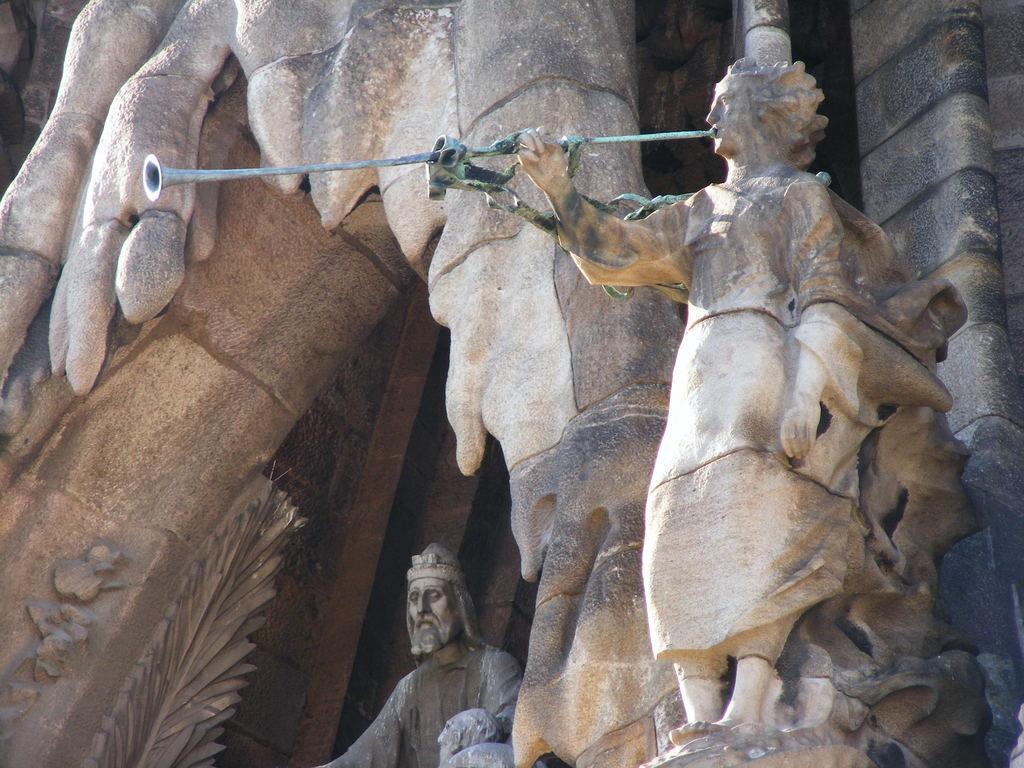Can you describe this image briefly? In the picture I can see sculptures and some other objects. I can also see some designs on the wall. 